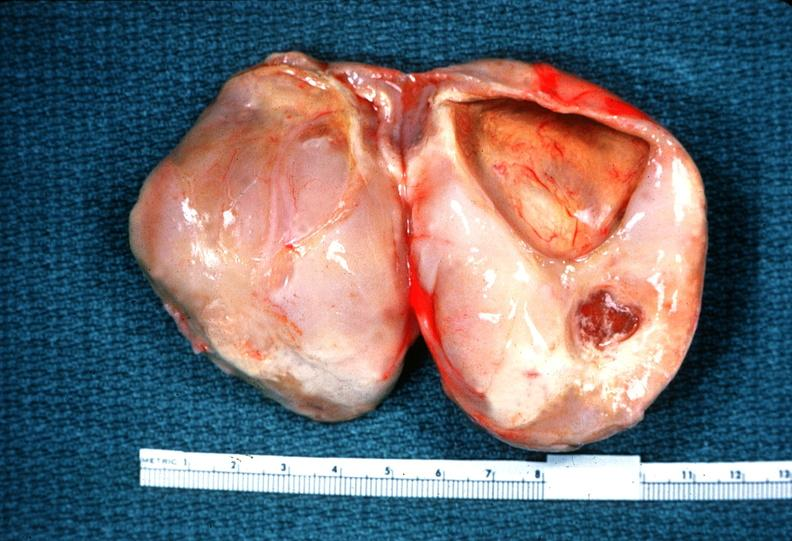s nervous present?
Answer the question using a single word or phrase. Yes 